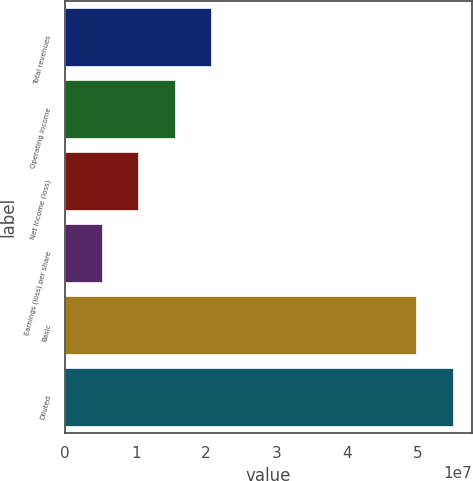Convert chart to OTSL. <chart><loc_0><loc_0><loc_500><loc_500><bar_chart><fcel>Total revenues<fcel>Operating income<fcel>Net income (loss)<fcel>Earnings (loss) per share<fcel>Basic<fcel>Diluted<nl><fcel>2.07429e+07<fcel>1.55572e+07<fcel>1.03715e+07<fcel>5.18573e+06<fcel>4.97842e+07<fcel>5.49699e+07<nl></chart> 